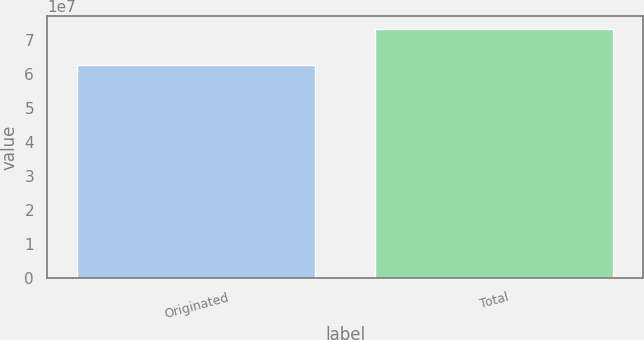Convert chart to OTSL. <chart><loc_0><loc_0><loc_500><loc_500><bar_chart><fcel>Originated<fcel>Total<nl><fcel>6.28138e+07<fcel>7.33821e+07<nl></chart> 